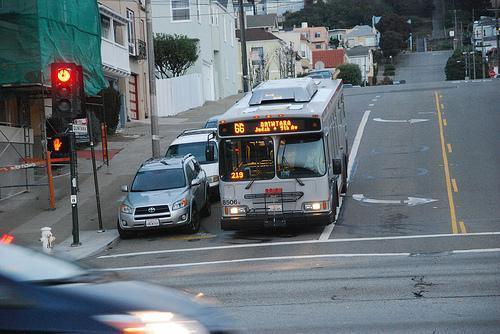How many buses iin the picture?
Give a very brief answer. 1. 